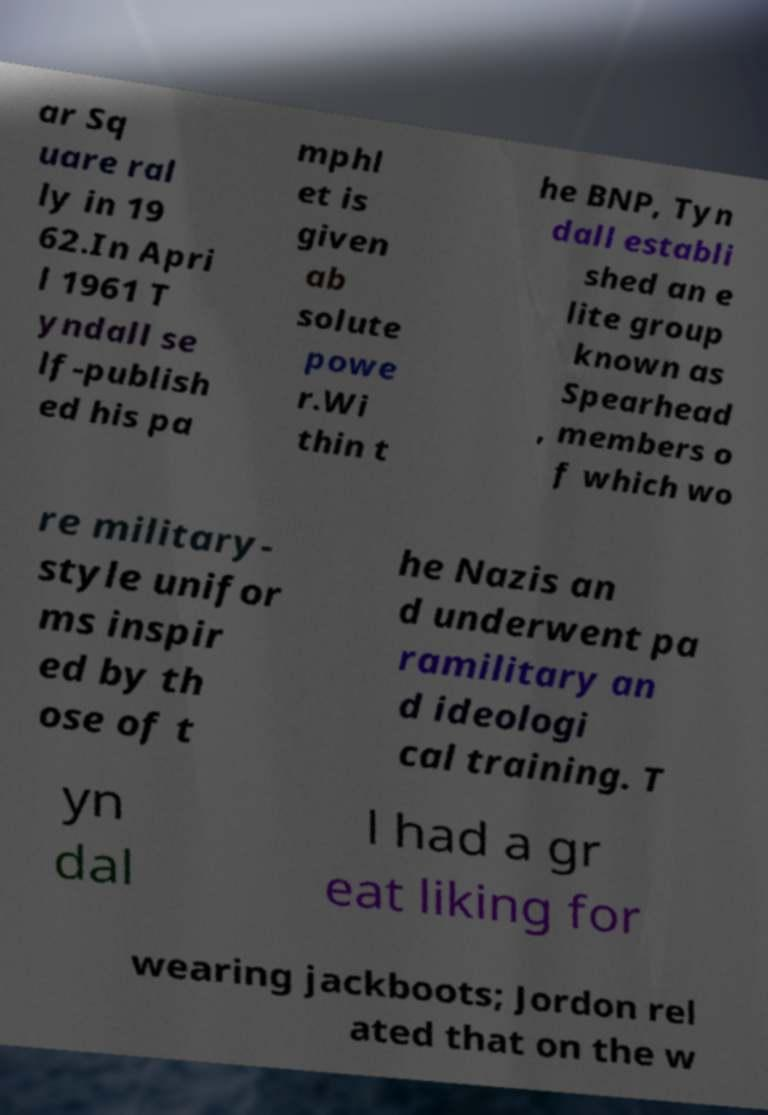I need the written content from this picture converted into text. Can you do that? ar Sq uare ral ly in 19 62.In Apri l 1961 T yndall se lf-publish ed his pa mphl et is given ab solute powe r.Wi thin t he BNP, Tyn dall establi shed an e lite group known as Spearhead , members o f which wo re military- style unifor ms inspir ed by th ose of t he Nazis an d underwent pa ramilitary an d ideologi cal training. T yn dal l had a gr eat liking for wearing jackboots; Jordon rel ated that on the w 